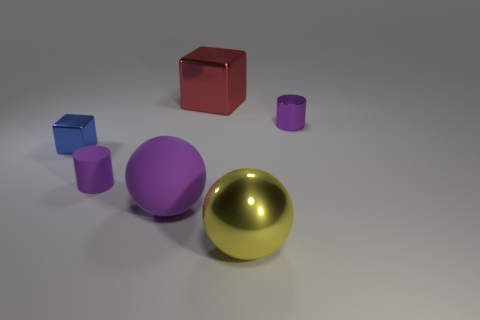Add 1 blue objects. How many objects exist? 7 Subtract 2 cubes. How many cubes are left? 0 Subtract all brown cylinders. Subtract all blue cubes. How many cylinders are left? 2 Subtract all tiny brown rubber spheres. Subtract all matte cylinders. How many objects are left? 5 Add 2 red shiny blocks. How many red shiny blocks are left? 3 Add 2 large rubber objects. How many large rubber objects exist? 3 Subtract 0 yellow cylinders. How many objects are left? 6 Subtract all blocks. How many objects are left? 4 